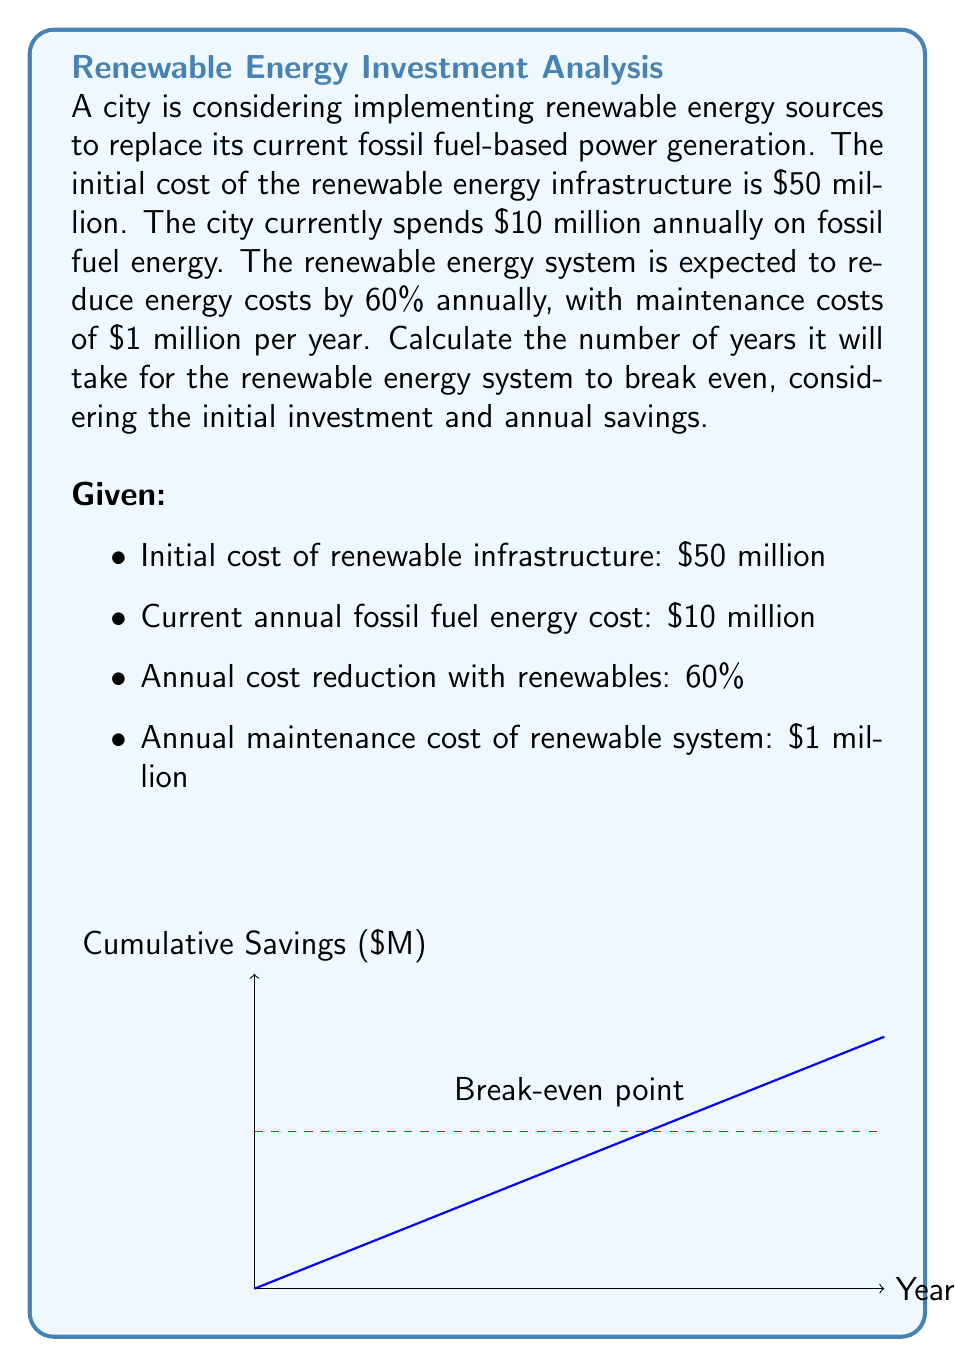Can you answer this question? Let's approach this step-by-step:

1) First, calculate the annual savings from switching to renewable energy:
   Annual savings = Current cost - (Current cost × (1 - Reduction percentage)) - Maintenance cost
   $$ \text{Annual savings} = 10,000,000 - (10,000,000 \times (1 - 0.60)) - 1,000,000 $$
   $$ = 10,000,000 - 4,000,000 - 1,000,000 = 5,000,000 $$

2) Now, we need to find how long it will take for these annual savings to equal the initial investment:
   Let $x$ be the number of years to break even.
   
   Initial investment = Annual savings × Number of years
   $$ 50,000,000 = 5,000,000x $$

3) Solve for $x$:
   $$ x = \frac{50,000,000}{5,000,000} = 10 $$

Therefore, it will take 10 years for the renewable energy system to break even.

To verify:
After 10 years, total savings = $5,000,000 × 10 = $50,000,000, which equals the initial investment.
Answer: 10 years 